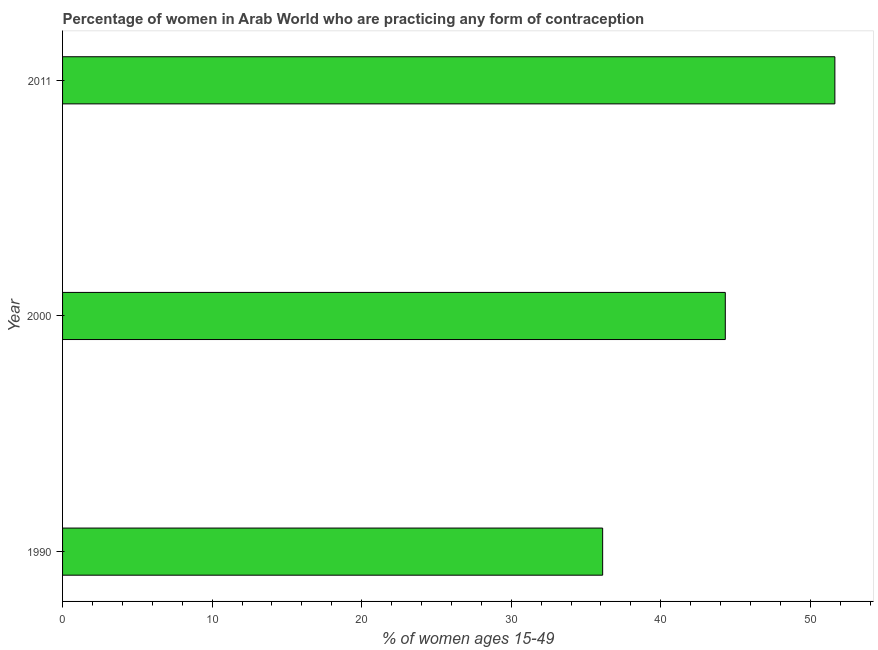Does the graph contain any zero values?
Your answer should be very brief. No. What is the title of the graph?
Make the answer very short. Percentage of women in Arab World who are practicing any form of contraception. What is the label or title of the X-axis?
Your answer should be very brief. % of women ages 15-49. What is the contraceptive prevalence in 2011?
Ensure brevity in your answer.  51.64. Across all years, what is the maximum contraceptive prevalence?
Make the answer very short. 51.64. Across all years, what is the minimum contraceptive prevalence?
Your answer should be compact. 36.11. In which year was the contraceptive prevalence maximum?
Provide a succinct answer. 2011. What is the sum of the contraceptive prevalence?
Make the answer very short. 132.07. What is the difference between the contraceptive prevalence in 1990 and 2011?
Keep it short and to the point. -15.53. What is the average contraceptive prevalence per year?
Keep it short and to the point. 44.02. What is the median contraceptive prevalence?
Your answer should be compact. 44.32. In how many years, is the contraceptive prevalence greater than 40 %?
Make the answer very short. 2. Do a majority of the years between 1990 and 2011 (inclusive) have contraceptive prevalence greater than 44 %?
Ensure brevity in your answer.  Yes. What is the ratio of the contraceptive prevalence in 1990 to that in 2000?
Make the answer very short. 0.81. Is the contraceptive prevalence in 1990 less than that in 2000?
Keep it short and to the point. Yes. Is the difference between the contraceptive prevalence in 1990 and 2000 greater than the difference between any two years?
Offer a very short reply. No. What is the difference between the highest and the second highest contraceptive prevalence?
Ensure brevity in your answer.  7.33. What is the difference between the highest and the lowest contraceptive prevalence?
Offer a very short reply. 15.53. Are all the bars in the graph horizontal?
Your response must be concise. Yes. What is the difference between two consecutive major ticks on the X-axis?
Make the answer very short. 10. Are the values on the major ticks of X-axis written in scientific E-notation?
Provide a short and direct response. No. What is the % of women ages 15-49 in 1990?
Your answer should be very brief. 36.11. What is the % of women ages 15-49 of 2000?
Provide a succinct answer. 44.32. What is the % of women ages 15-49 in 2011?
Your answer should be very brief. 51.64. What is the difference between the % of women ages 15-49 in 1990 and 2000?
Make the answer very short. -8.2. What is the difference between the % of women ages 15-49 in 1990 and 2011?
Your response must be concise. -15.53. What is the difference between the % of women ages 15-49 in 2000 and 2011?
Offer a very short reply. -7.33. What is the ratio of the % of women ages 15-49 in 1990 to that in 2000?
Offer a terse response. 0.81. What is the ratio of the % of women ages 15-49 in 1990 to that in 2011?
Give a very brief answer. 0.7. What is the ratio of the % of women ages 15-49 in 2000 to that in 2011?
Make the answer very short. 0.86. 